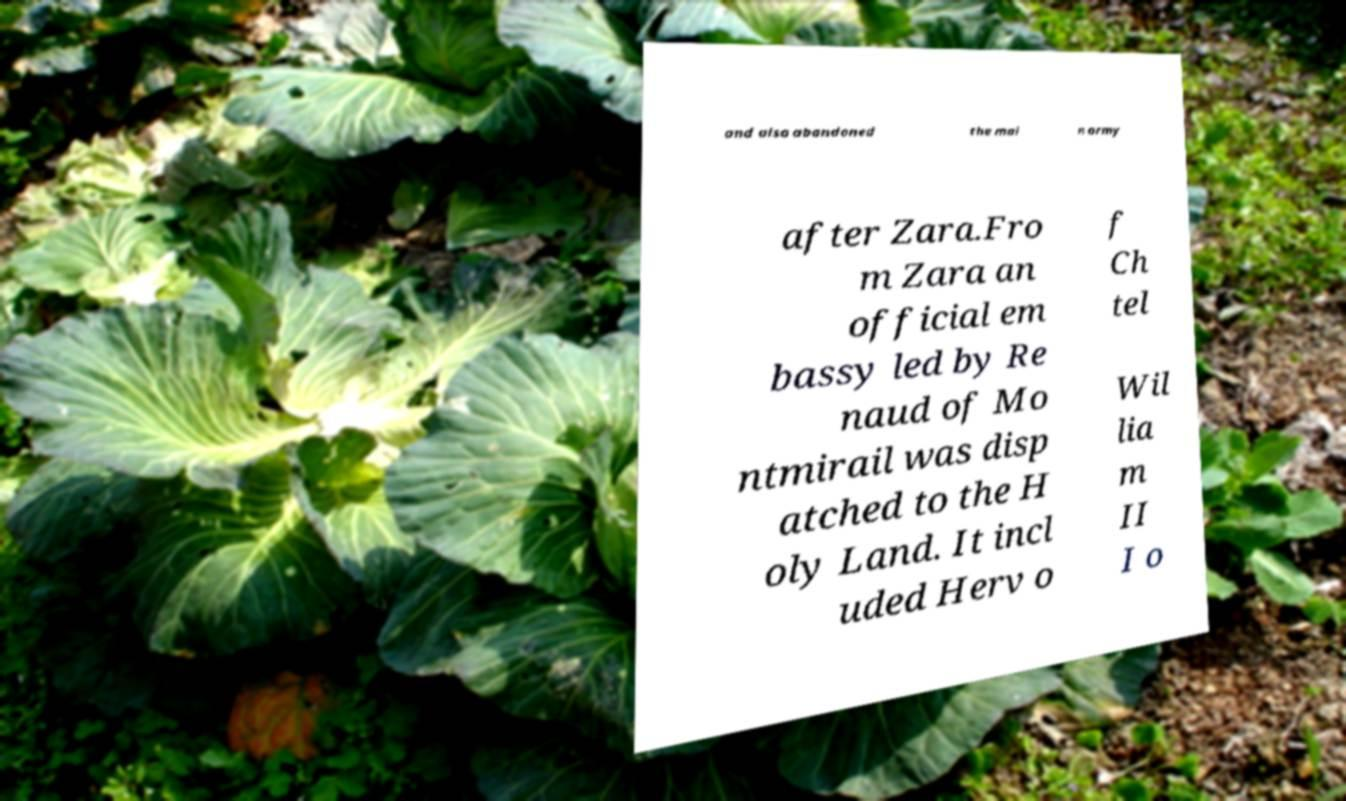I need the written content from this picture converted into text. Can you do that? and also abandoned the mai n army after Zara.Fro m Zara an official em bassy led by Re naud of Mo ntmirail was disp atched to the H oly Land. It incl uded Herv o f Ch tel Wil lia m II I o 